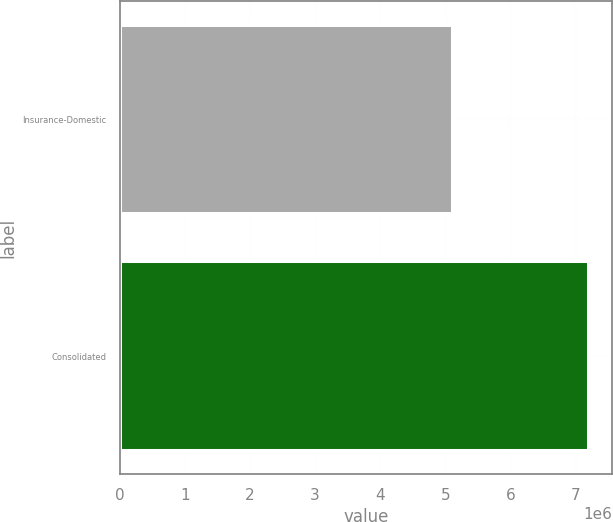Convert chart to OTSL. <chart><loc_0><loc_0><loc_500><loc_500><bar_chart><fcel>Insurance-Domestic<fcel>Consolidated<nl><fcel>5.11478e+06<fcel>7.20646e+06<nl></chart> 